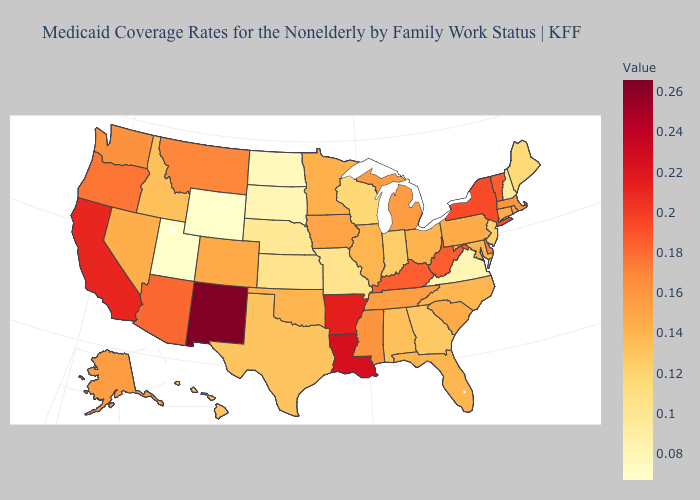Among the states that border South Dakota , does Montana have the lowest value?
Keep it brief. No. Among the states that border Pennsylvania , does New Jersey have the lowest value?
Quick response, please. Yes. Among the states that border Illinois , does Indiana have the lowest value?
Keep it brief. No. Does California have a lower value than New Mexico?
Short answer required. Yes. Does the map have missing data?
Write a very short answer. No. Does Louisiana have the highest value in the South?
Answer briefly. Yes. Among the states that border Wyoming , does South Dakota have the lowest value?
Write a very short answer. No. 